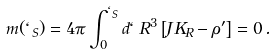Convert formula to latex. <formula><loc_0><loc_0><loc_500><loc_500>m ( \ell _ { S } ) = 4 \pi \int _ { 0 } ^ { \ell _ { S } } d \ell \, R ^ { 3 } \left [ J K _ { R } - \rho ^ { \prime } \right ] = 0 \, .</formula> 